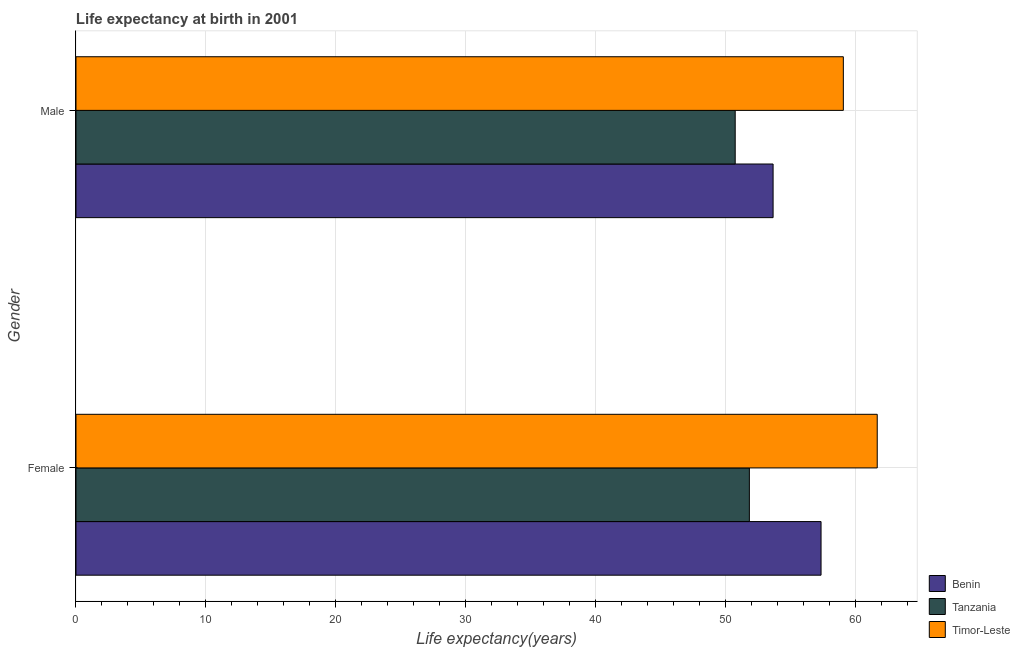How many different coloured bars are there?
Give a very brief answer. 3. How many groups of bars are there?
Provide a short and direct response. 2. Are the number of bars per tick equal to the number of legend labels?
Provide a succinct answer. Yes. What is the label of the 1st group of bars from the top?
Offer a terse response. Male. What is the life expectancy(male) in Benin?
Your response must be concise. 53.67. Across all countries, what is the maximum life expectancy(male)?
Offer a very short reply. 59.07. Across all countries, what is the minimum life expectancy(female)?
Your answer should be very brief. 51.84. In which country was the life expectancy(female) maximum?
Your answer should be very brief. Timor-Leste. In which country was the life expectancy(female) minimum?
Offer a very short reply. Tanzania. What is the total life expectancy(male) in the graph?
Your response must be concise. 163.49. What is the difference between the life expectancy(female) in Tanzania and that in Timor-Leste?
Keep it short and to the point. -9.84. What is the difference between the life expectancy(male) in Tanzania and the life expectancy(female) in Benin?
Your response must be concise. -6.61. What is the average life expectancy(female) per country?
Your answer should be very brief. 56.96. What is the difference between the life expectancy(female) and life expectancy(male) in Tanzania?
Make the answer very short. 1.09. In how many countries, is the life expectancy(female) greater than 10 years?
Provide a short and direct response. 3. What is the ratio of the life expectancy(female) in Tanzania to that in Timor-Leste?
Keep it short and to the point. 0.84. In how many countries, is the life expectancy(female) greater than the average life expectancy(female) taken over all countries?
Your answer should be very brief. 2. What does the 3rd bar from the top in Male represents?
Your answer should be very brief. Benin. What does the 1st bar from the bottom in Female represents?
Your response must be concise. Benin. Are all the bars in the graph horizontal?
Offer a terse response. Yes. How many countries are there in the graph?
Offer a terse response. 3. How many legend labels are there?
Give a very brief answer. 3. What is the title of the graph?
Your answer should be compact. Life expectancy at birth in 2001. What is the label or title of the X-axis?
Your answer should be very brief. Life expectancy(years). What is the label or title of the Y-axis?
Make the answer very short. Gender. What is the Life expectancy(years) in Benin in Female?
Give a very brief answer. 57.36. What is the Life expectancy(years) of Tanzania in Female?
Make the answer very short. 51.84. What is the Life expectancy(years) in Timor-Leste in Female?
Provide a short and direct response. 61.68. What is the Life expectancy(years) in Benin in Male?
Offer a terse response. 53.67. What is the Life expectancy(years) in Tanzania in Male?
Your answer should be very brief. 50.75. What is the Life expectancy(years) of Timor-Leste in Male?
Keep it short and to the point. 59.07. Across all Gender, what is the maximum Life expectancy(years) of Benin?
Give a very brief answer. 57.36. Across all Gender, what is the maximum Life expectancy(years) of Tanzania?
Offer a very short reply. 51.84. Across all Gender, what is the maximum Life expectancy(years) in Timor-Leste?
Give a very brief answer. 61.68. Across all Gender, what is the minimum Life expectancy(years) of Benin?
Provide a succinct answer. 53.67. Across all Gender, what is the minimum Life expectancy(years) in Tanzania?
Provide a short and direct response. 50.75. Across all Gender, what is the minimum Life expectancy(years) in Timor-Leste?
Your response must be concise. 59.07. What is the total Life expectancy(years) in Benin in the graph?
Keep it short and to the point. 111.02. What is the total Life expectancy(years) of Tanzania in the graph?
Your answer should be compact. 102.59. What is the total Life expectancy(years) of Timor-Leste in the graph?
Your answer should be compact. 120.76. What is the difference between the Life expectancy(years) of Benin in Female and that in Male?
Provide a succinct answer. 3.69. What is the difference between the Life expectancy(years) of Tanzania in Female and that in Male?
Make the answer very short. 1.09. What is the difference between the Life expectancy(years) of Timor-Leste in Female and that in Male?
Make the answer very short. 2.61. What is the difference between the Life expectancy(years) in Benin in Female and the Life expectancy(years) in Tanzania in Male?
Give a very brief answer. 6.61. What is the difference between the Life expectancy(years) in Benin in Female and the Life expectancy(years) in Timor-Leste in Male?
Keep it short and to the point. -1.72. What is the difference between the Life expectancy(years) of Tanzania in Female and the Life expectancy(years) of Timor-Leste in Male?
Make the answer very short. -7.24. What is the average Life expectancy(years) in Benin per Gender?
Ensure brevity in your answer.  55.51. What is the average Life expectancy(years) of Tanzania per Gender?
Ensure brevity in your answer.  51.29. What is the average Life expectancy(years) in Timor-Leste per Gender?
Provide a short and direct response. 60.38. What is the difference between the Life expectancy(years) in Benin and Life expectancy(years) in Tanzania in Female?
Offer a very short reply. 5.52. What is the difference between the Life expectancy(years) in Benin and Life expectancy(years) in Timor-Leste in Female?
Your response must be concise. -4.33. What is the difference between the Life expectancy(years) in Tanzania and Life expectancy(years) in Timor-Leste in Female?
Keep it short and to the point. -9.84. What is the difference between the Life expectancy(years) of Benin and Life expectancy(years) of Tanzania in Male?
Provide a short and direct response. 2.92. What is the difference between the Life expectancy(years) of Benin and Life expectancy(years) of Timor-Leste in Male?
Offer a terse response. -5.41. What is the difference between the Life expectancy(years) of Tanzania and Life expectancy(years) of Timor-Leste in Male?
Ensure brevity in your answer.  -8.32. What is the ratio of the Life expectancy(years) of Benin in Female to that in Male?
Keep it short and to the point. 1.07. What is the ratio of the Life expectancy(years) in Tanzania in Female to that in Male?
Keep it short and to the point. 1.02. What is the ratio of the Life expectancy(years) in Timor-Leste in Female to that in Male?
Offer a very short reply. 1.04. What is the difference between the highest and the second highest Life expectancy(years) in Benin?
Provide a short and direct response. 3.69. What is the difference between the highest and the second highest Life expectancy(years) of Tanzania?
Make the answer very short. 1.09. What is the difference between the highest and the second highest Life expectancy(years) in Timor-Leste?
Offer a very short reply. 2.61. What is the difference between the highest and the lowest Life expectancy(years) of Benin?
Offer a very short reply. 3.69. What is the difference between the highest and the lowest Life expectancy(years) in Tanzania?
Keep it short and to the point. 1.09. What is the difference between the highest and the lowest Life expectancy(years) of Timor-Leste?
Give a very brief answer. 2.61. 